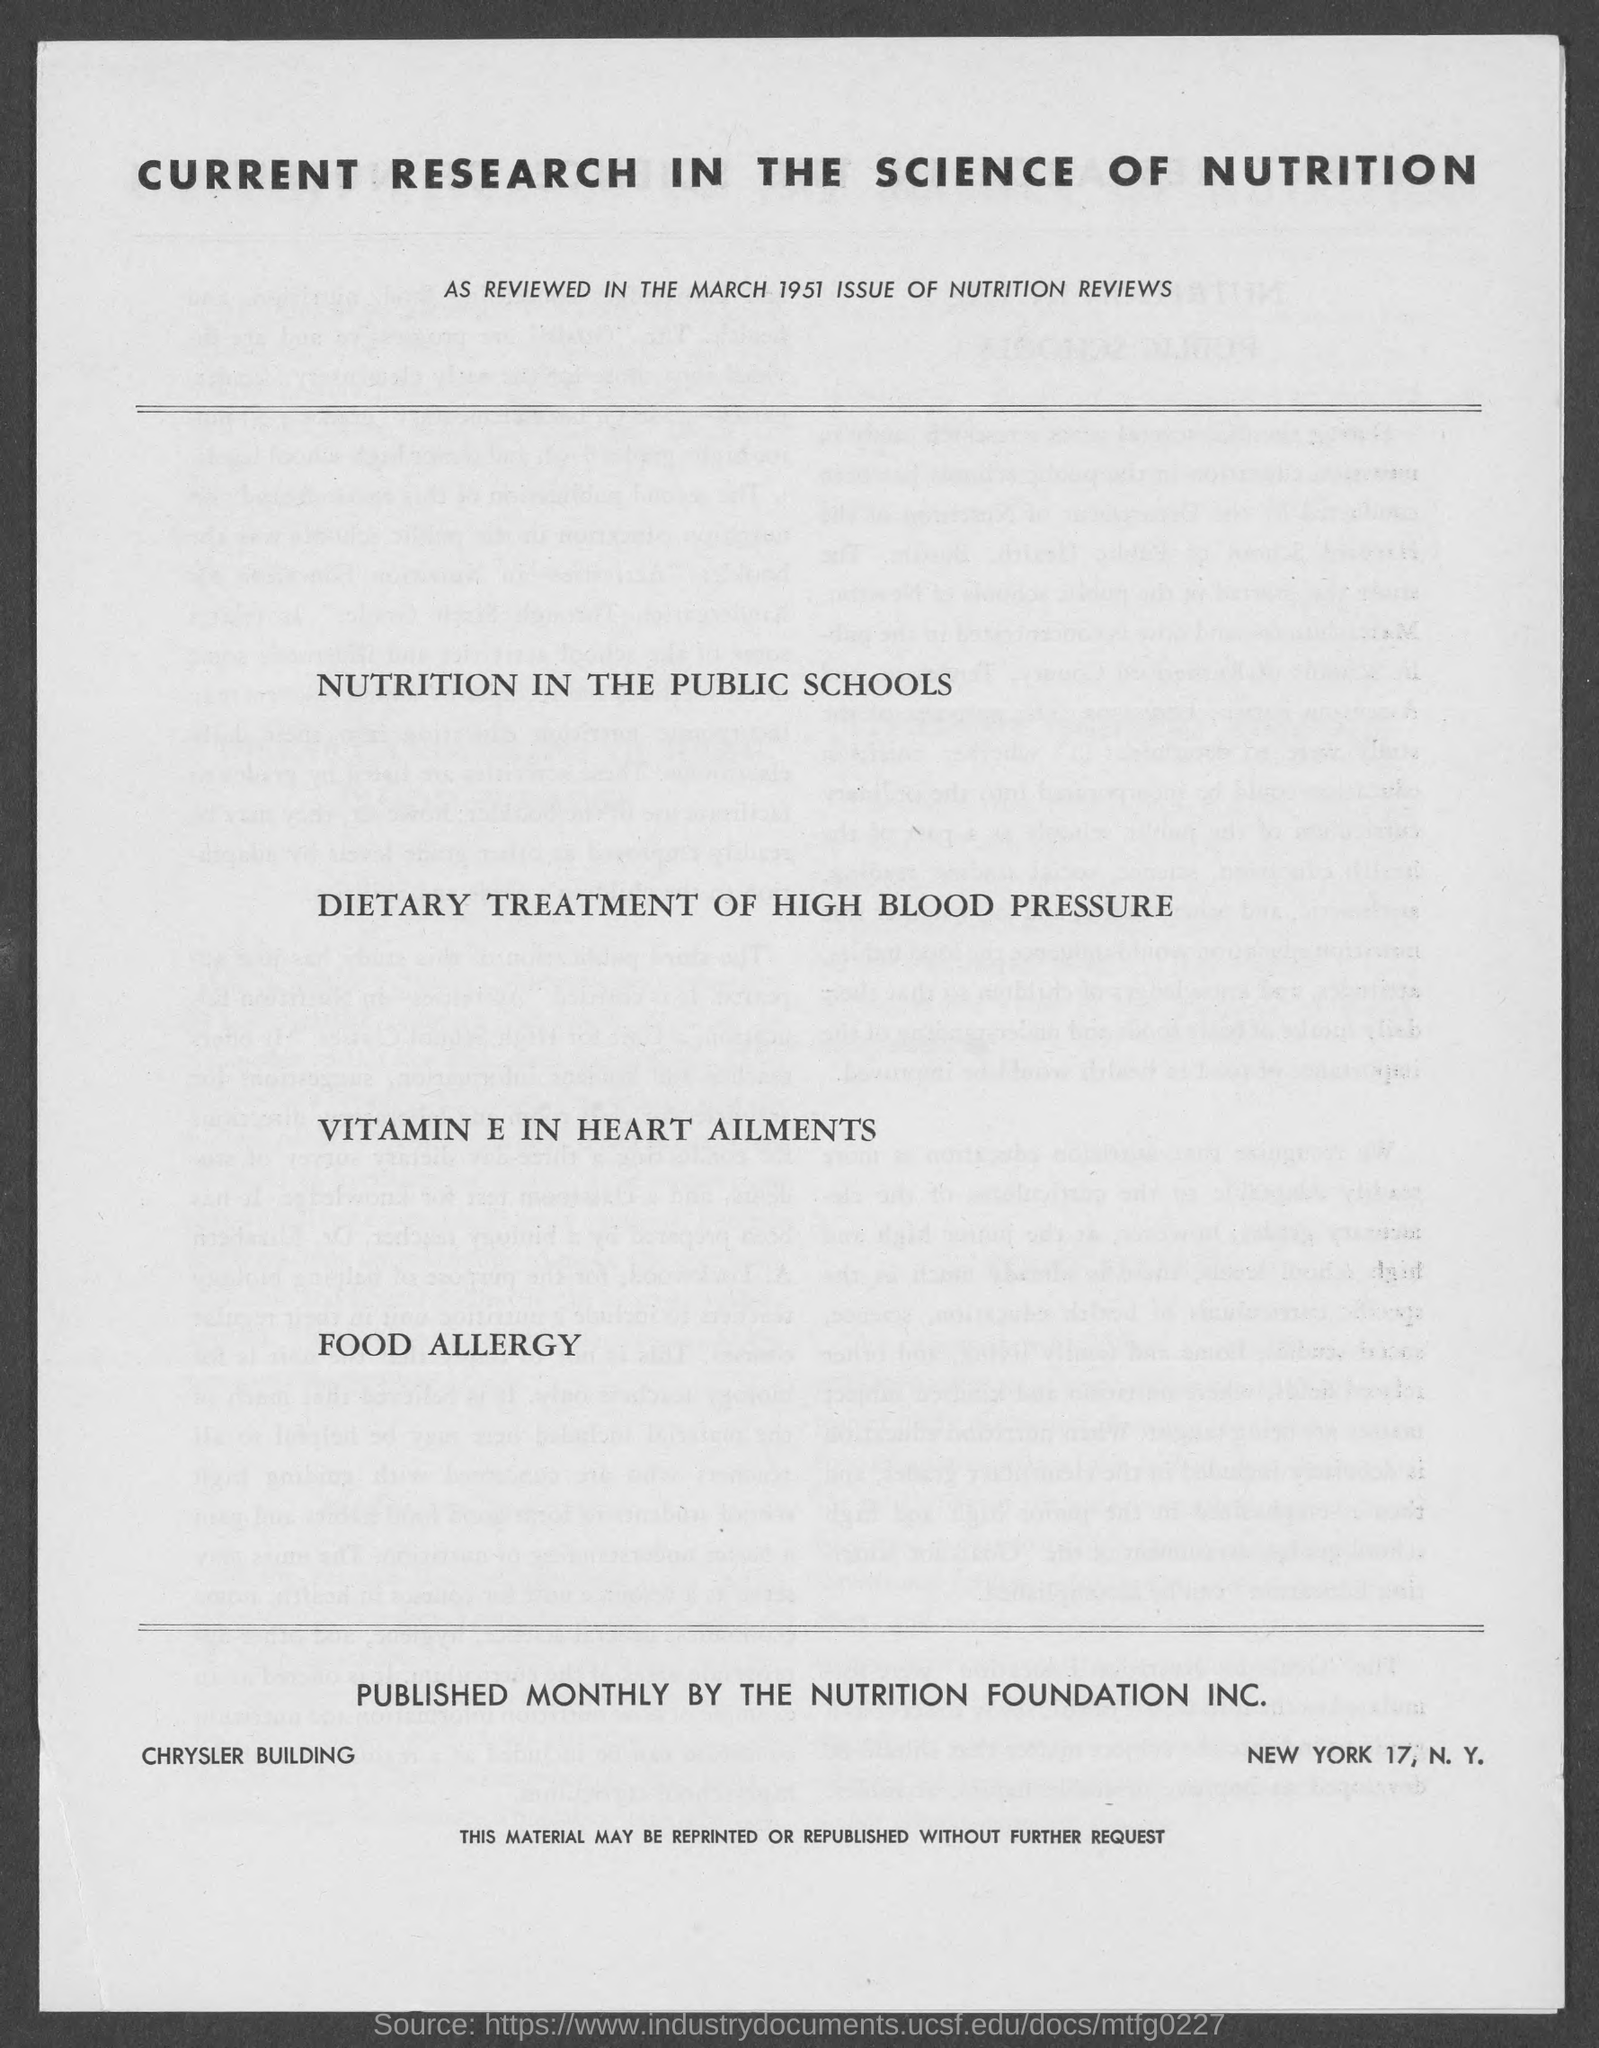In which year it was reviewed?
Offer a terse response. 1951. Published monthly by which foundation?
Your response must be concise. Nutrition foundation inc. What is the building name mentioned?
Give a very brief answer. Chrysler Building. 